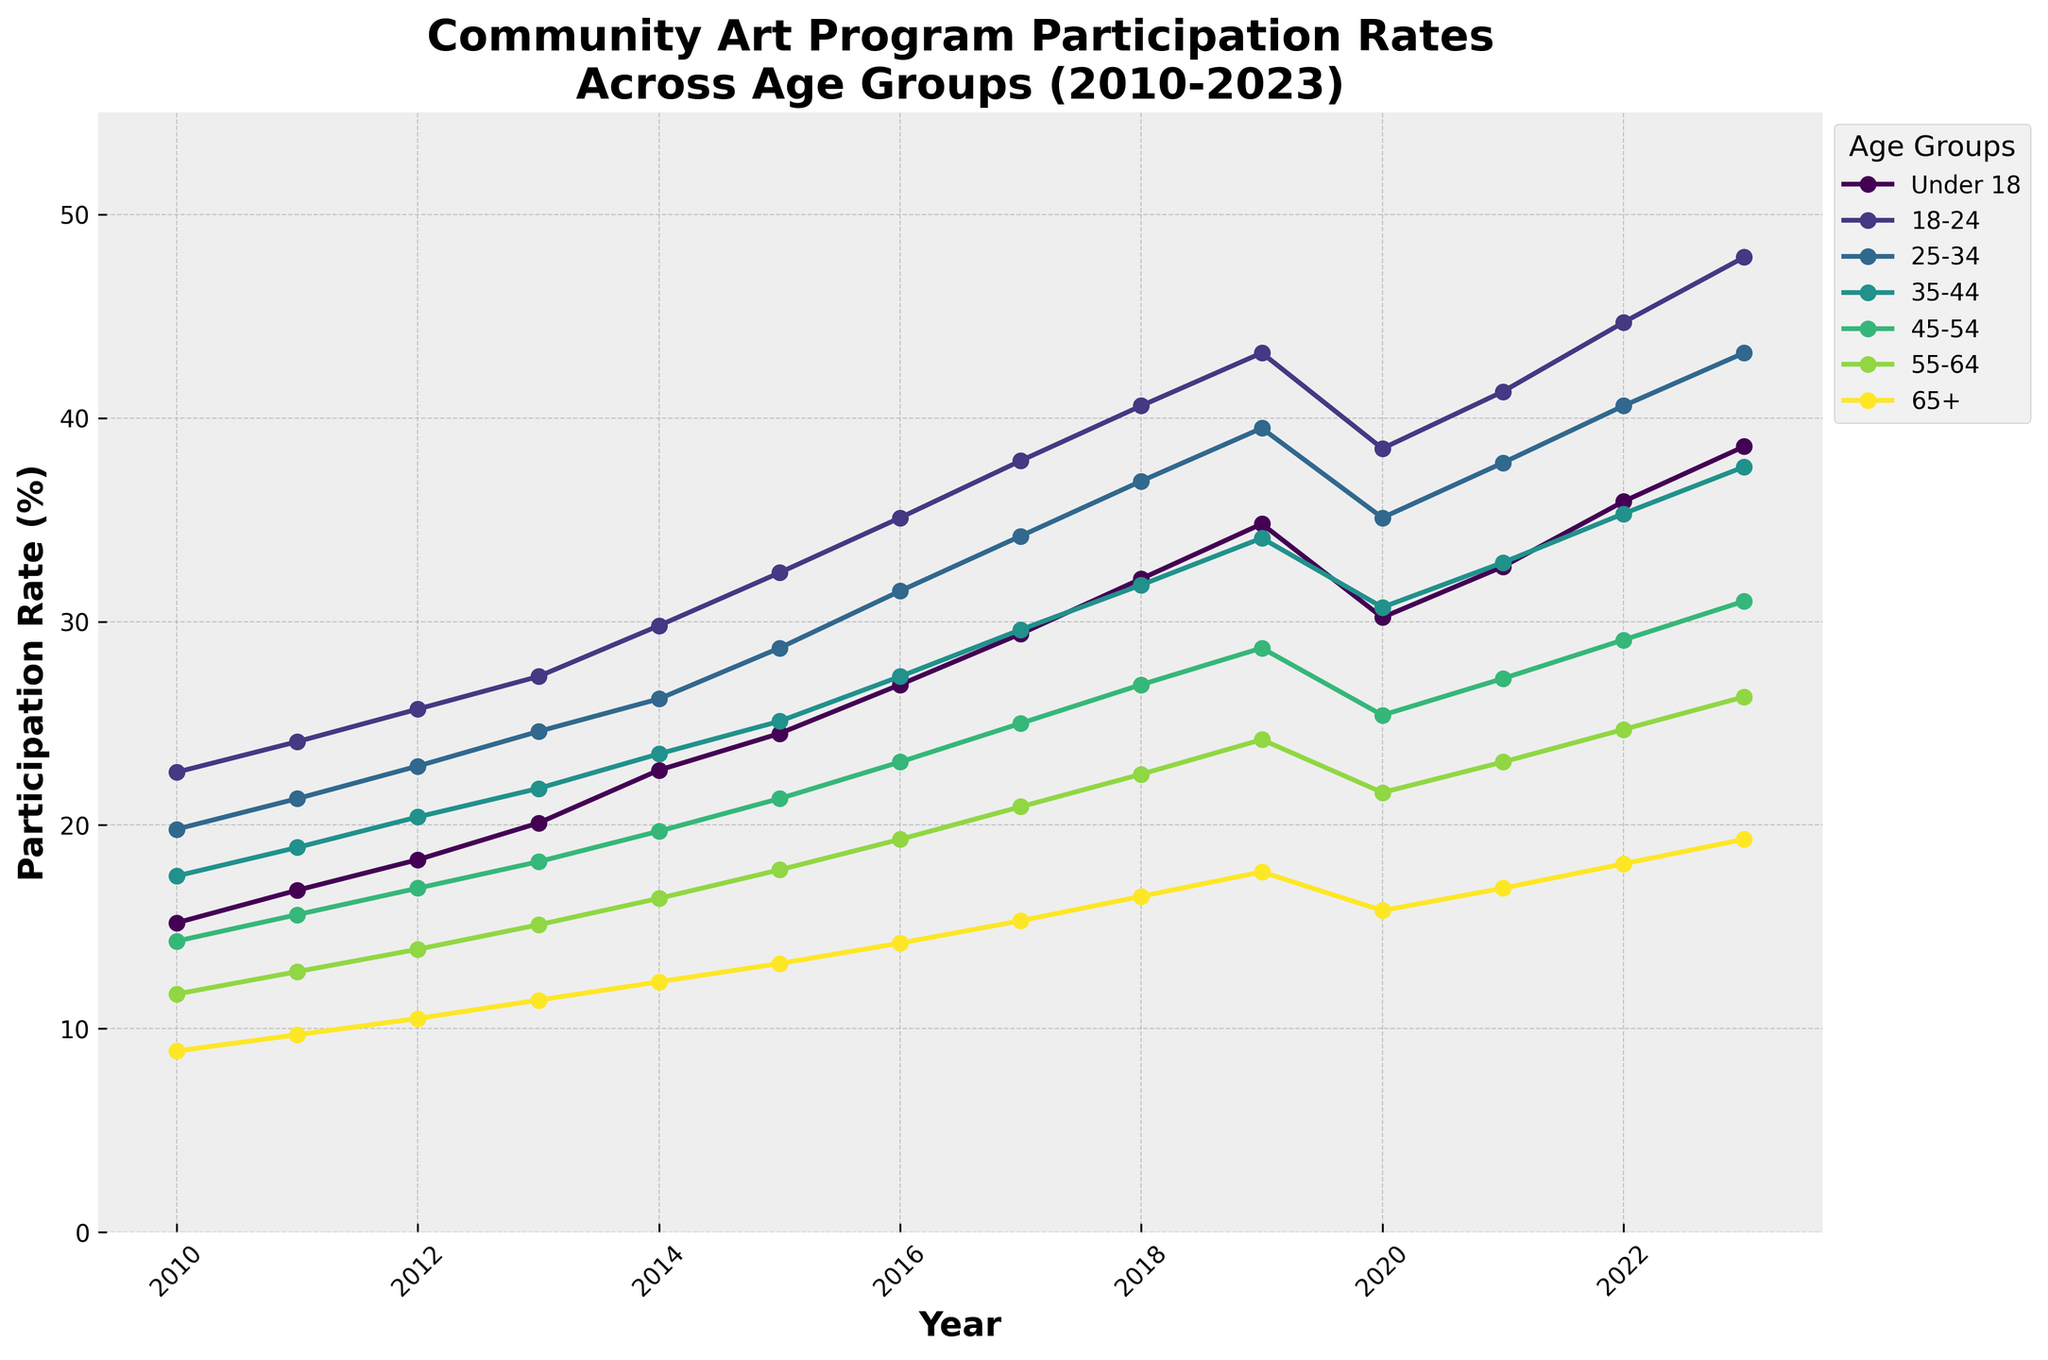What age group shows the highest participation rate in 2023? Look at the endpoints of each line on the right side of the chart for 2023 and identify which line is the highest.
Answer: 18-24 Which age group had the steepest increase in participation rate between 2010 and 2023? Compare the slope of each line by looking at the vertical distance between the start (2010) and the end (2023) for each age group.
Answer: Under 18 How did the participation rate for the 45-54 age group change from 2019 to 2020? Observe the line segment for the 45-54 age group between 2019 and 2020; the rate decreased from 28.7% to 25.4%.
Answer: Decreased Which age groups had a dip in participation in 2020? Identify the points in 2020 and see if they are lower than those in 2019 for each age group. The age groups Under 18, 18-24, 25-34, 35-44, and 45-54 show dips.
Answer: Under 18, 18-24, 25-34, 35-44, 45-54 Compare the participation rate of the 65+ age group between 2010 and 2023. Has it increased or decreased? Observe the start point in 2010 and the end point in 2023 for the 65+ line. The line moves upwards from 8.9% to 19.3%.
Answer: Increased What is the average participation rate for the 35-44 age group across all years? Sum all the participation rates for the 35-44 age group and divide by the number of years (14). Total: 17.5 + 18.9 + 20.4 + 21.8 + 23.5 + 25.1 + 27.3 + 29.6 + 31.8 + 34.1 + 30.7 + 32.9 + 35.3 + 37.6 = 386.5, Average = 386.5 / 14
Answer: 27.6 Which year shows the highest participation rate for the Under 18 age group? Trace the line for the Under 18 age group and identify the peak, which occurs at 2023 with a rate of 38.6%.
Answer: 2023 